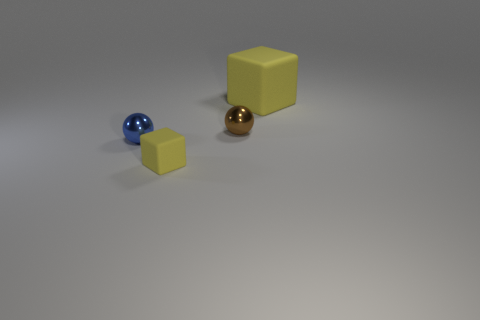Add 3 large blue rubber cylinders. How many objects exist? 7 Subtract all brown balls. How many balls are left? 1 Subtract 2 cubes. How many cubes are left? 0 Subtract all red blocks. How many yellow balls are left? 0 Subtract all yellow spheres. Subtract all gray blocks. How many spheres are left? 2 Subtract all small blue metallic spheres. Subtract all tiny red metal cylinders. How many objects are left? 3 Add 1 blue things. How many blue things are left? 2 Add 2 small blue balls. How many small blue balls exist? 3 Subtract 0 red cylinders. How many objects are left? 4 